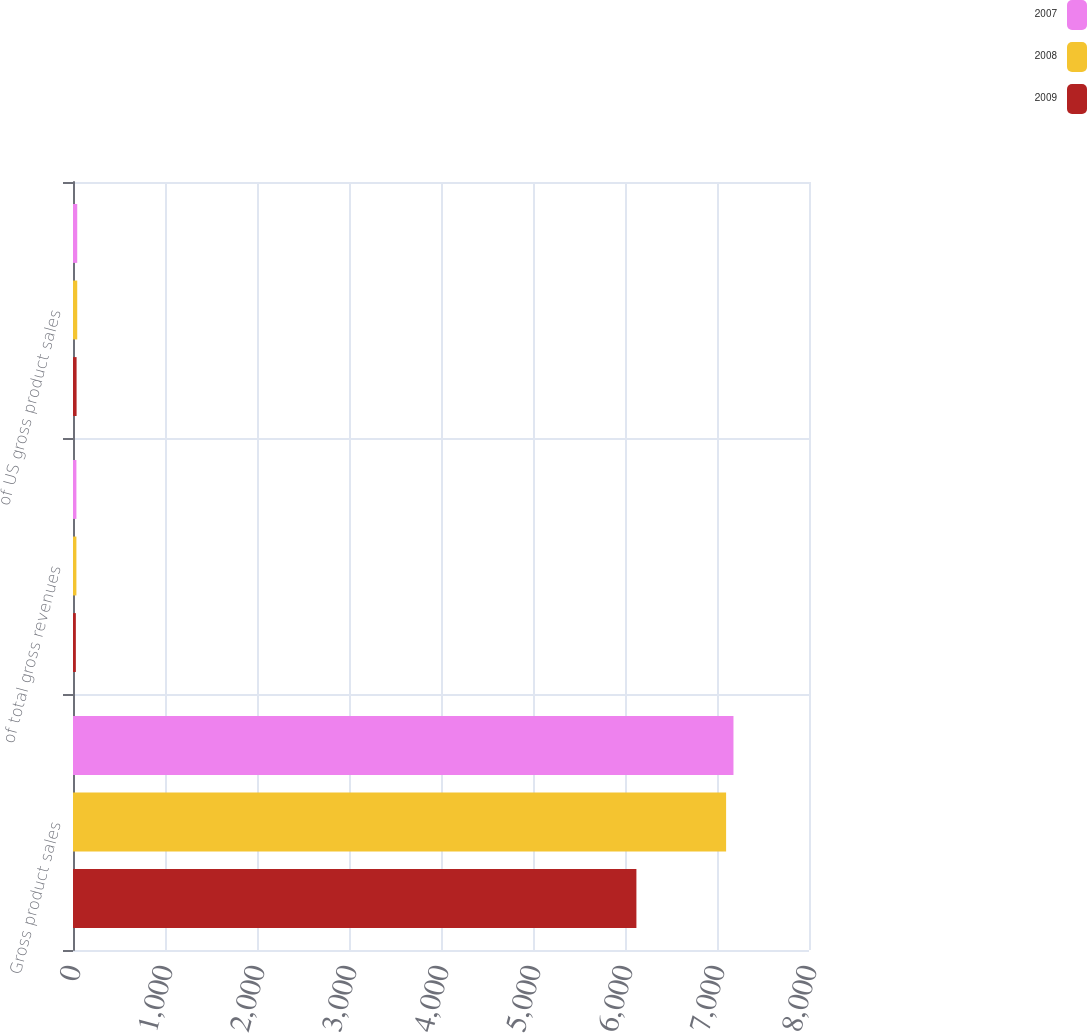Convert chart to OTSL. <chart><loc_0><loc_0><loc_500><loc_500><stacked_bar_chart><ecel><fcel>Gross product sales<fcel>of total gross revenues<fcel>of US gross product sales<nl><fcel>2007<fcel>7179<fcel>37<fcel>46<nl><fcel>2008<fcel>7099<fcel>37<fcel>46<nl><fcel>2009<fcel>6124<fcel>31<fcel>39<nl></chart> 